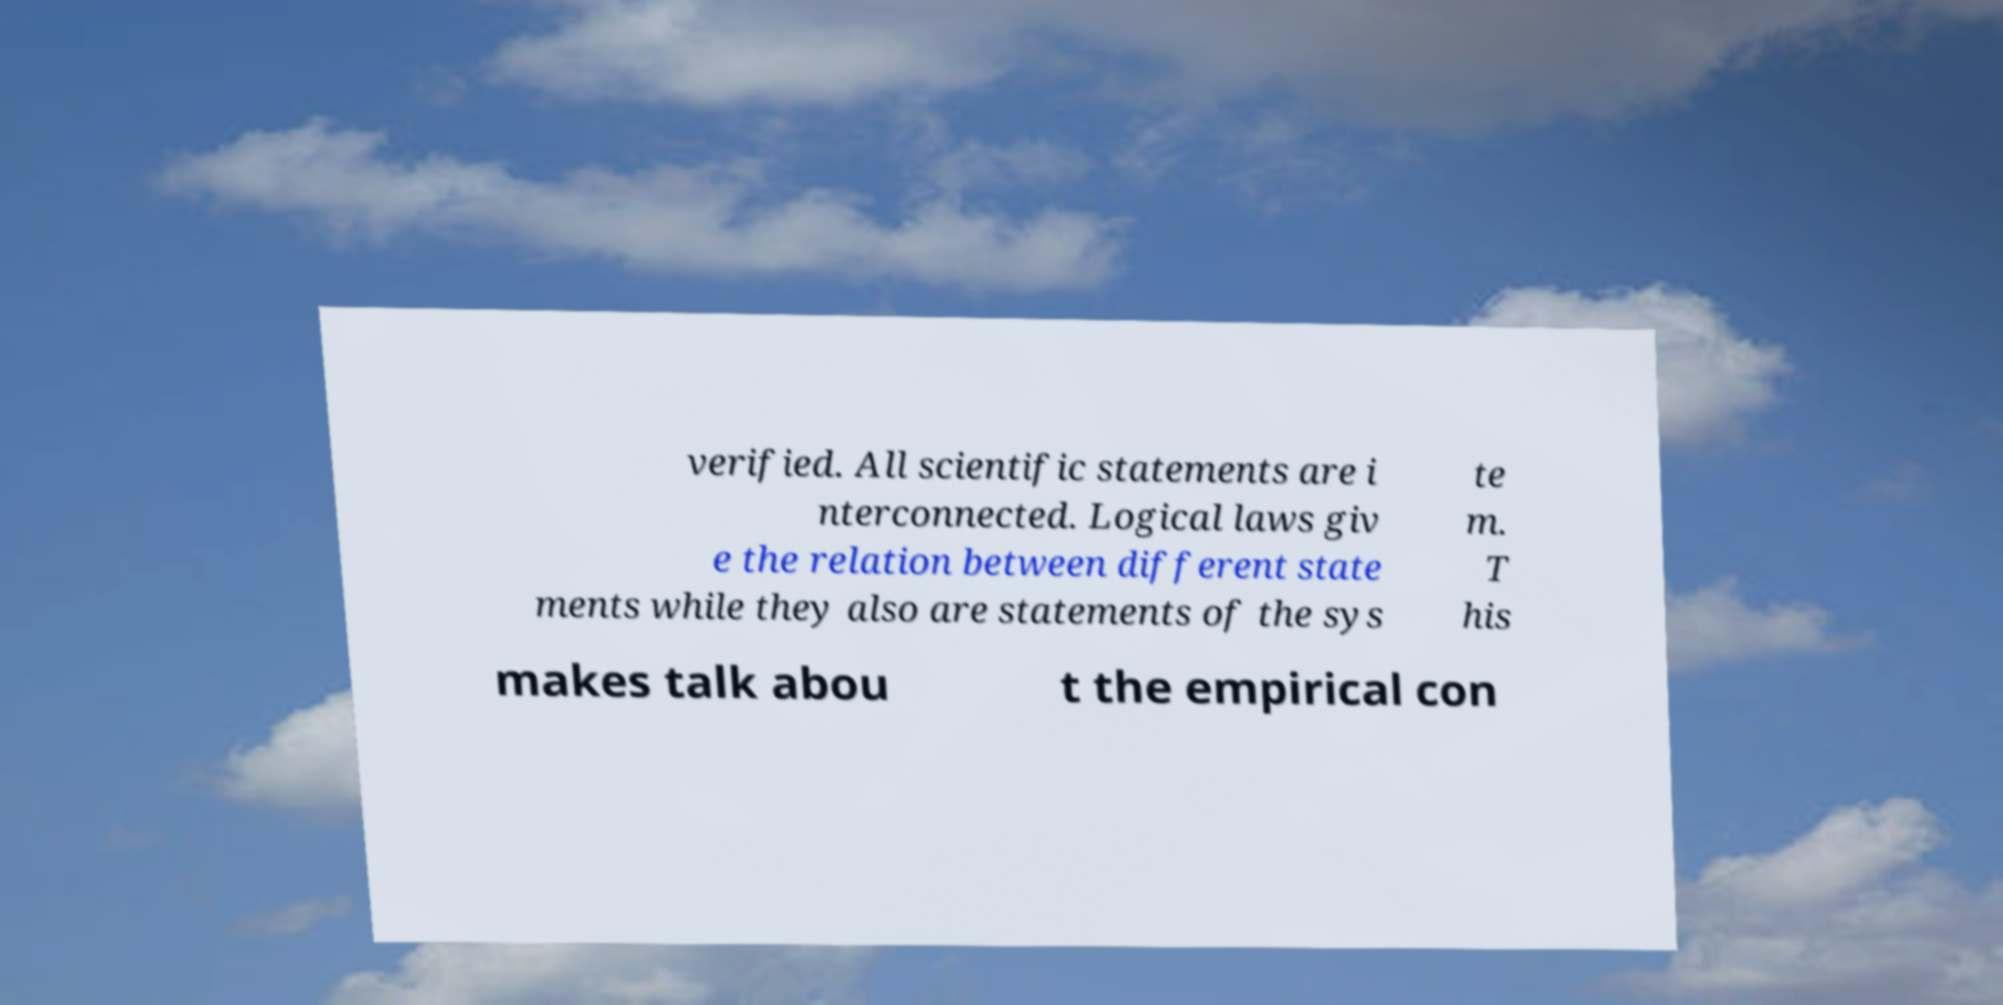Can you read and provide the text displayed in the image?This photo seems to have some interesting text. Can you extract and type it out for me? verified. All scientific statements are i nterconnected. Logical laws giv e the relation between different state ments while they also are statements of the sys te m. T his makes talk abou t the empirical con 